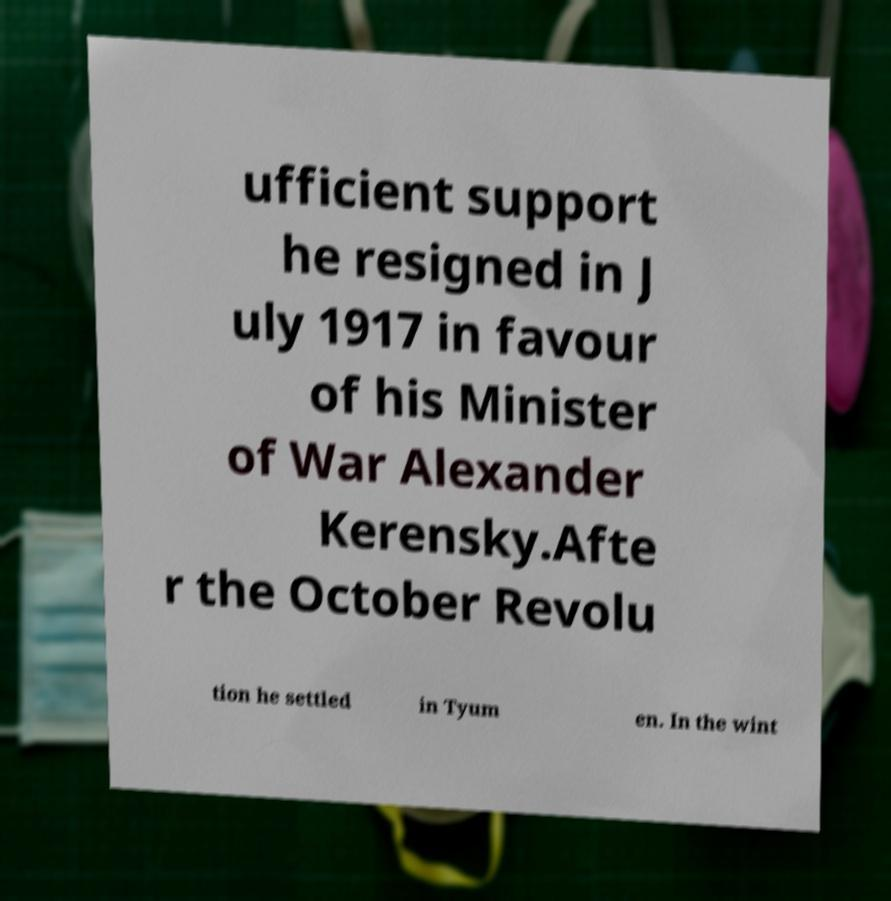There's text embedded in this image that I need extracted. Can you transcribe it verbatim? ufficient support he resigned in J uly 1917 in favour of his Minister of War Alexander Kerensky.Afte r the October Revolu tion he settled in Tyum en. In the wint 